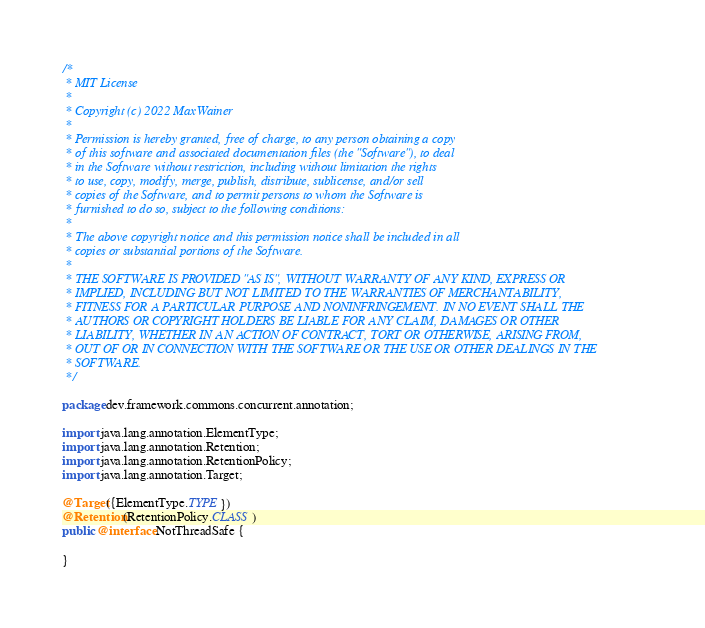<code> <loc_0><loc_0><loc_500><loc_500><_Java_>/*
 * MIT License
 *
 * Copyright (c) 2022 MaxWainer
 *
 * Permission is hereby granted, free of charge, to any person obtaining a copy
 * of this software and associated documentation files (the "Software"), to deal
 * in the Software without restriction, including without limitation the rights
 * to use, copy, modify, merge, publish, distribute, sublicense, and/or sell
 * copies of the Software, and to permit persons to whom the Software is
 * furnished to do so, subject to the following conditions:
 *
 * The above copyright notice and this permission notice shall be included in all
 * copies or substantial portions of the Software.
 *
 * THE SOFTWARE IS PROVIDED "AS IS", WITHOUT WARRANTY OF ANY KIND, EXPRESS OR
 * IMPLIED, INCLUDING BUT NOT LIMITED TO THE WARRANTIES OF MERCHANTABILITY,
 * FITNESS FOR A PARTICULAR PURPOSE AND NONINFRINGEMENT. IN NO EVENT SHALL THE
 * AUTHORS OR COPYRIGHT HOLDERS BE LIABLE FOR ANY CLAIM, DAMAGES OR OTHER
 * LIABILITY, WHETHER IN AN ACTION OF CONTRACT, TORT OR OTHERWISE, ARISING FROM,
 * OUT OF OR IN CONNECTION WITH THE SOFTWARE OR THE USE OR OTHER DEALINGS IN THE
 * SOFTWARE.
 */

package dev.framework.commons.concurrent.annotation;

import java.lang.annotation.ElementType;
import java.lang.annotation.Retention;
import java.lang.annotation.RetentionPolicy;
import java.lang.annotation.Target;

@Target({ElementType.TYPE})
@Retention(RetentionPolicy.CLASS)
public @interface NotThreadSafe {

}
</code> 